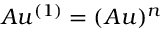<formula> <loc_0><loc_0><loc_500><loc_500>A u ^ { ( 1 ) } = ( A u ) ^ { n }</formula> 